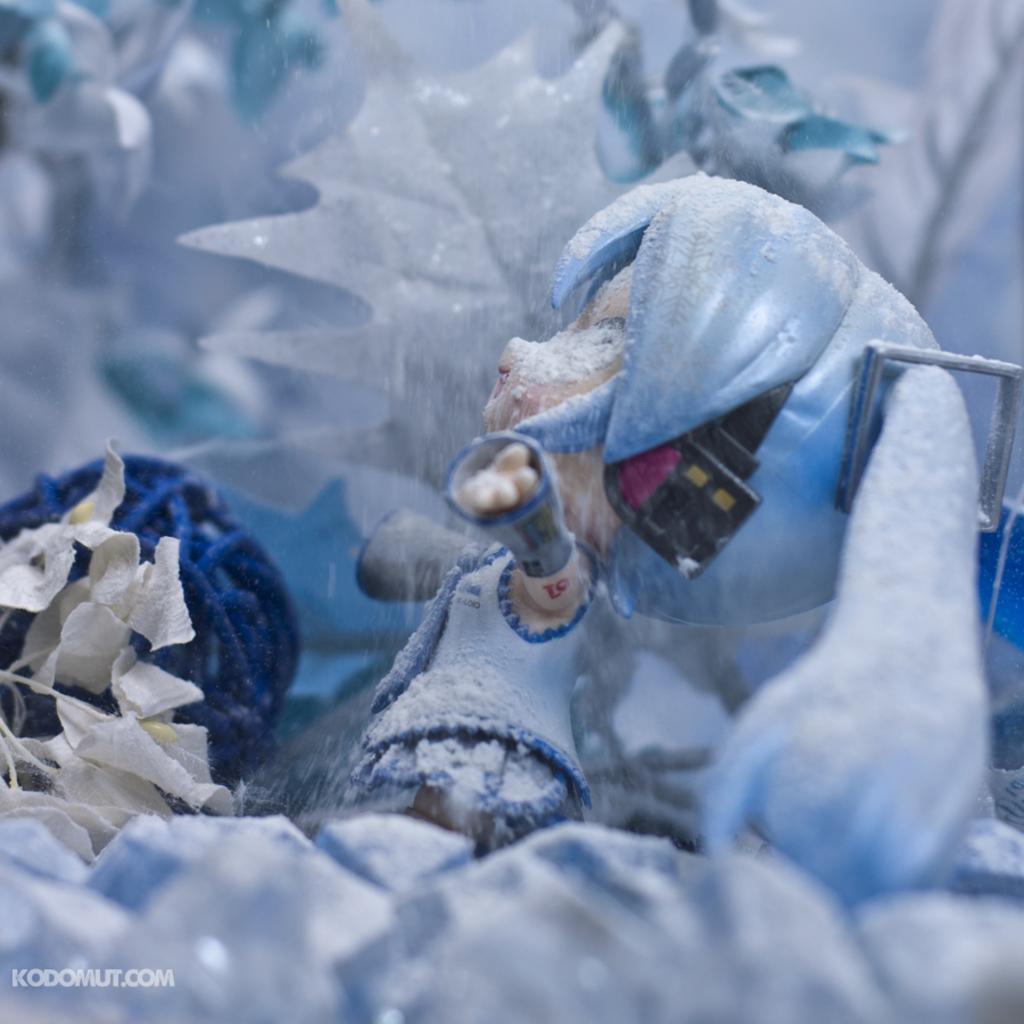Please provide a concise description of this image. In this picture we can see a toy and a watermark. 